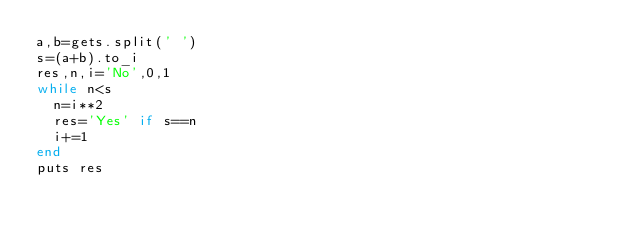<code> <loc_0><loc_0><loc_500><loc_500><_Ruby_>a,b=gets.split(' ')
s=(a+b).to_i
res,n,i='No',0,1
while n<s
  n=i**2
  res='Yes' if s==n
  i+=1 
end
puts res</code> 